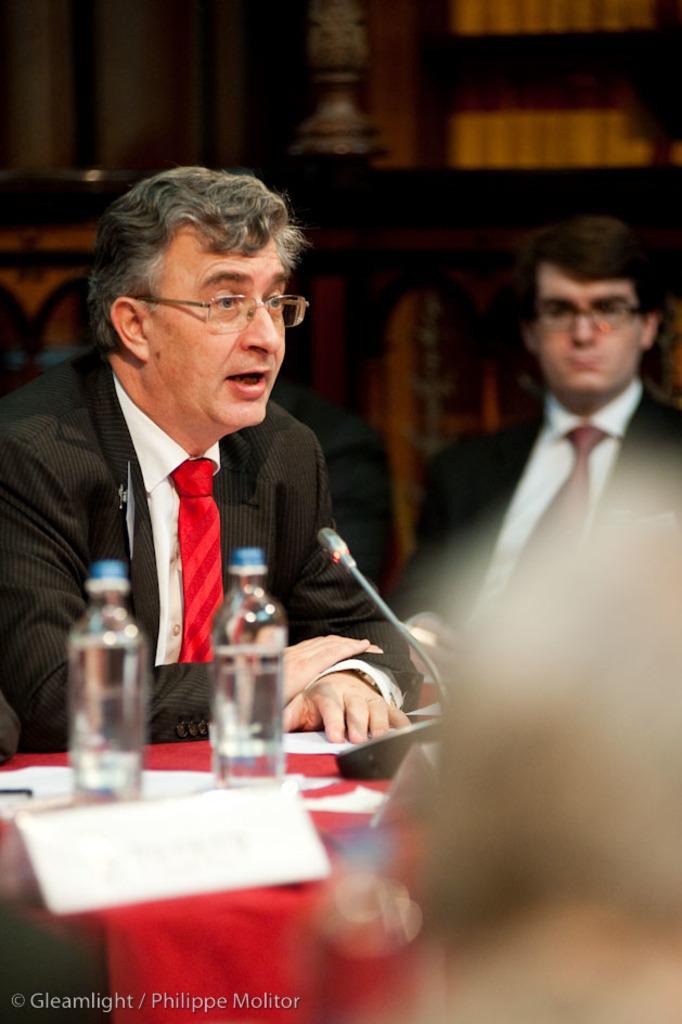Could you give a brief overview of what you see in this image? I think this picture is inside the room. There are two persons in the image, the person with black suit and red tie is sitting and talking, the other person at the back is sitting and listening. There are bottles, microphone, papers on the table, table is covered with red color cloth. 